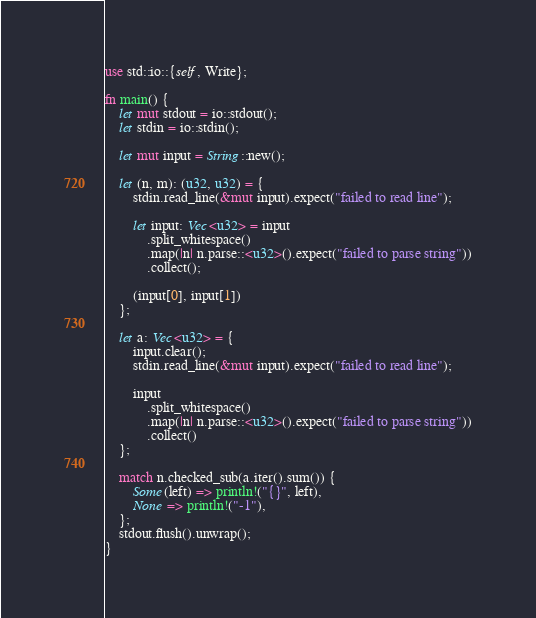Convert code to text. <code><loc_0><loc_0><loc_500><loc_500><_Rust_>use std::io::{self, Write};

fn main() {
    let mut stdout = io::stdout();
    let stdin = io::stdin();
    
    let mut input = String::new();

    let (n, m): (u32, u32) = {
        stdin.read_line(&mut input).expect("failed to read line");
        
        let input: Vec<u32> = input
            .split_whitespace()
            .map(|n| n.parse::<u32>().expect("failed to parse string"))
            .collect();

        (input[0], input[1])
    };
    
    let a: Vec<u32> = {
        input.clear();
        stdin.read_line(&mut input).expect("failed to read line");

        input
            .split_whitespace()
            .map(|n| n.parse::<u32>().expect("failed to parse string"))
            .collect()
    };

    match n.checked_sub(a.iter().sum()) {
        Some(left) => println!("{}", left),
        None => println!("-1"),
    };
    stdout.flush().unwrap();
}</code> 